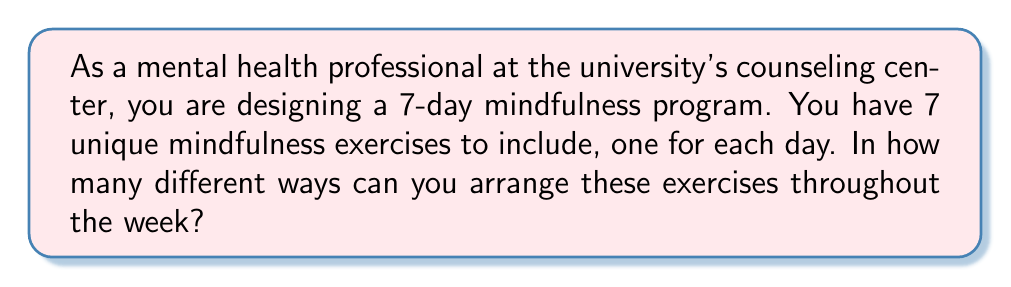Help me with this question. Let's approach this step-by-step:

1) We have 7 unique mindfulness exercises, and we need to arrange all 7 of them.

2) This is a permutation problem, as the order matters (the sequence of exercises over the week is important) and we are using all the exercises.

3) The formula for permutations of n distinct objects is:

   $$P(n) = n!$$

   where n is the number of objects and ! denotes factorial.

4) In this case, n = 7, so we need to calculate:

   $$P(7) = 7!$$

5) Let's expand this:

   $$7! = 7 \times 6 \times 5 \times 4 \times 3 \times 2 \times 1$$

6) Calculating this out:

   $$7! = 5040$$

Therefore, there are 5040 different ways to arrange the 7 mindfulness exercises over the 7-day program.
Answer: 5040 